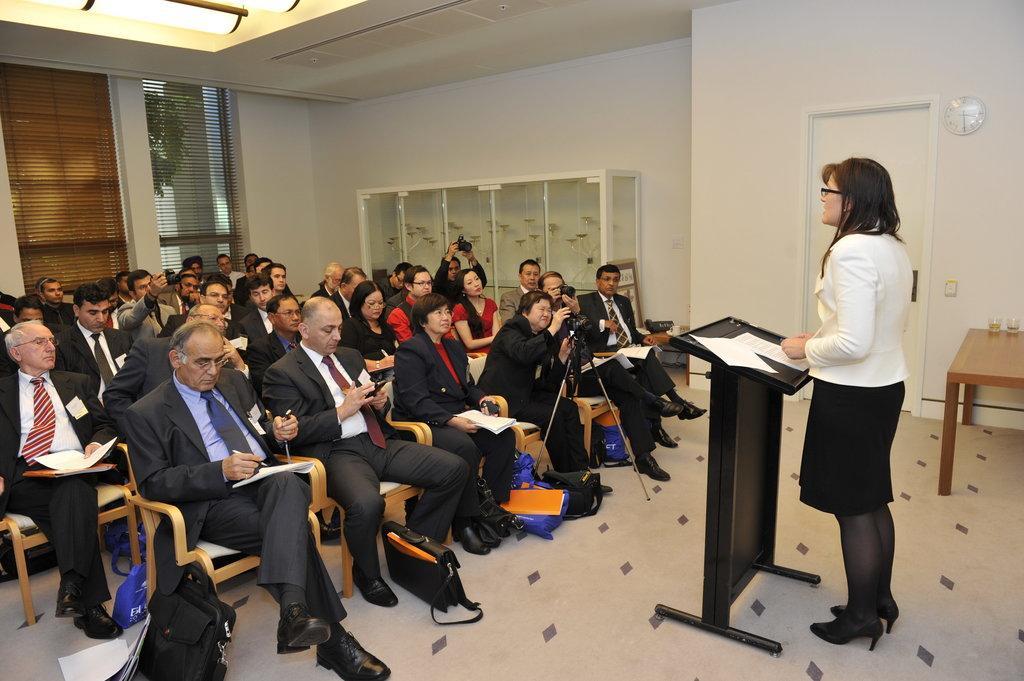Please provide a concise description of this image. In this image I can see group of people are sitting on the chairs and few people are holding books, pens, mobile and few people are holding cameras. I can see one person is standing in front of the podium and I can see few papers on it. Back I can see few windows, door, clock, wall and few objects on the table. 